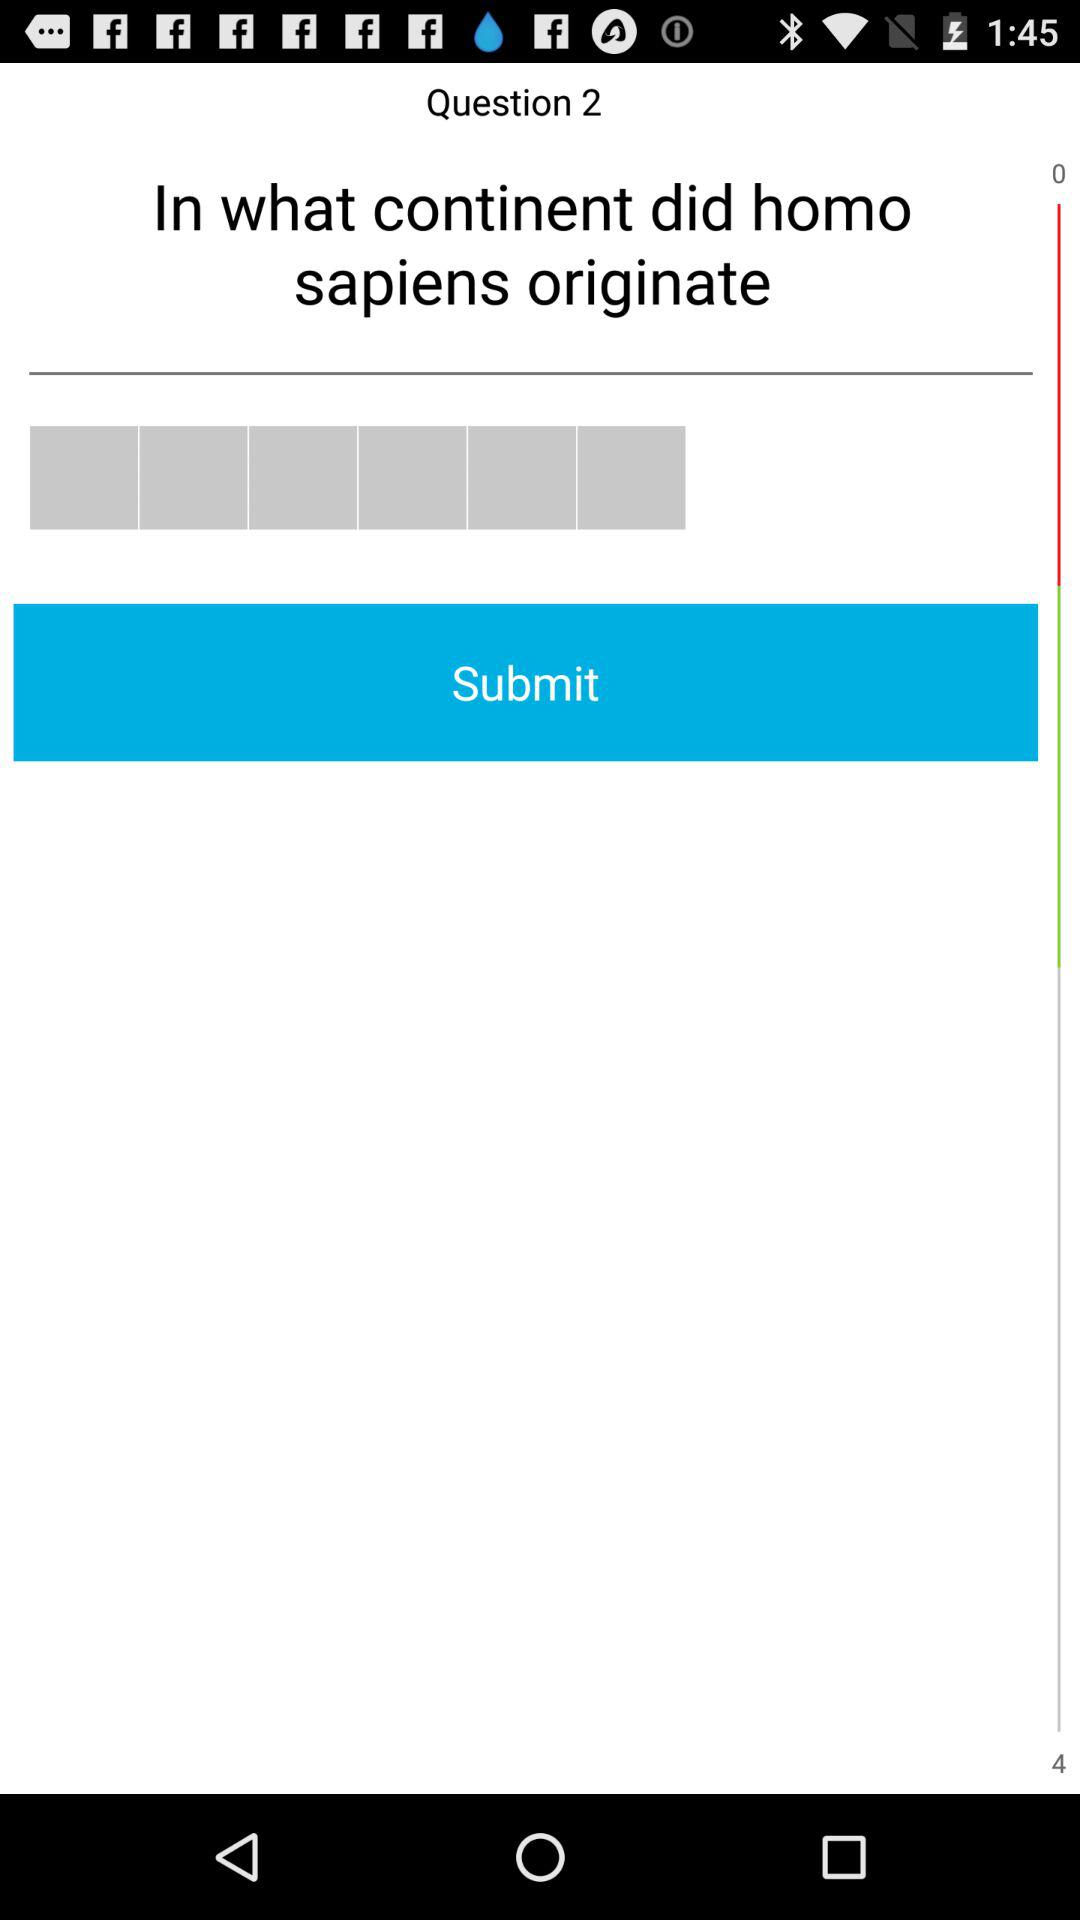What question number is this? This is question number 2. 